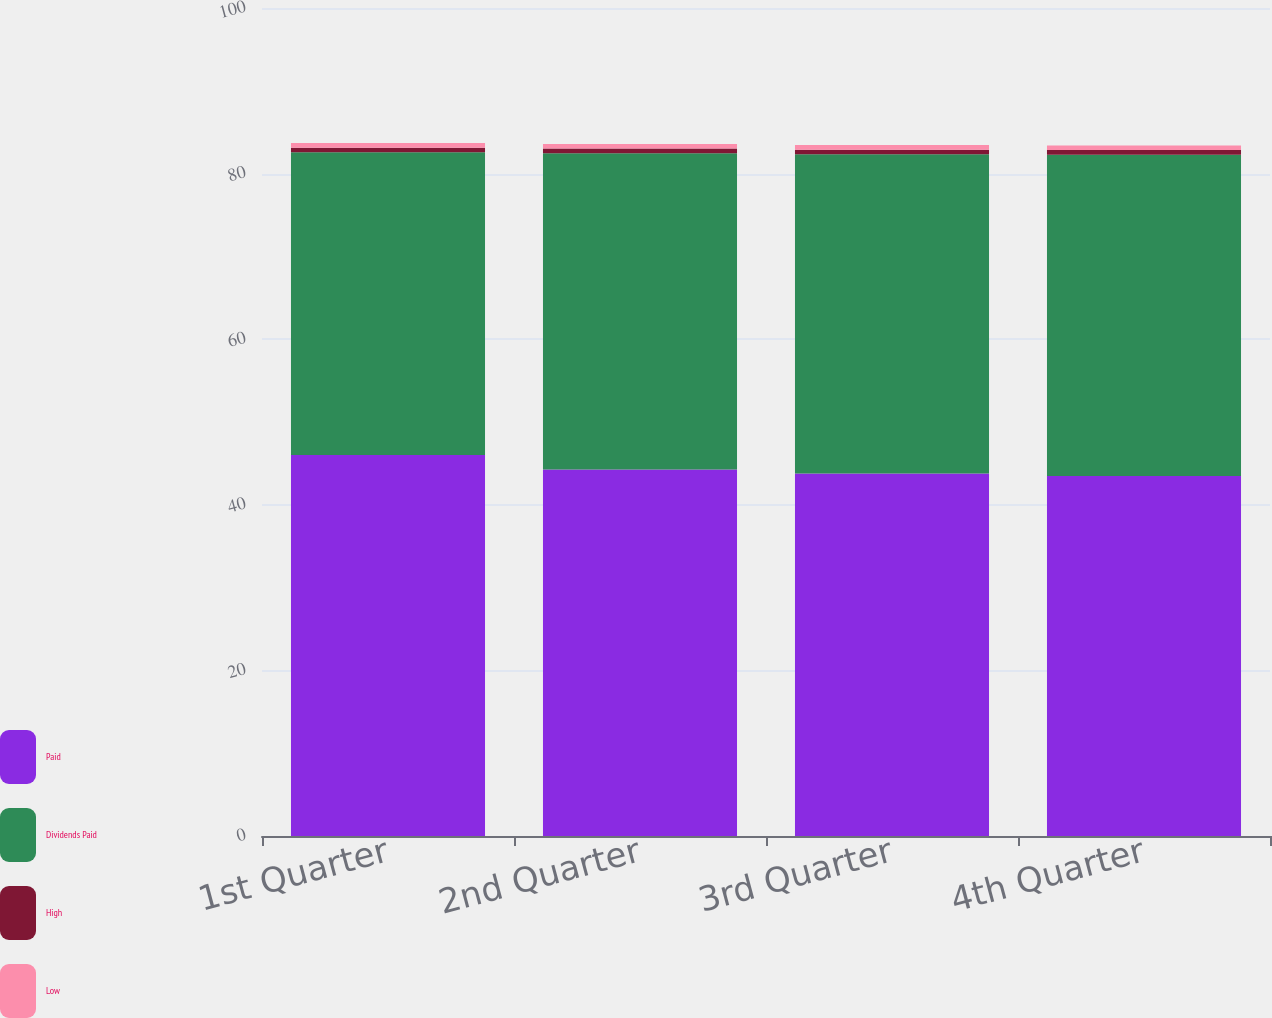<chart> <loc_0><loc_0><loc_500><loc_500><stacked_bar_chart><ecel><fcel>1st Quarter<fcel>2nd Quarter<fcel>3rd Quarter<fcel>4th Quarter<nl><fcel>Paid<fcel>46.02<fcel>44.26<fcel>43.78<fcel>43.48<nl><fcel>Dividends Paid<fcel>36.55<fcel>38.2<fcel>38.55<fcel>38.8<nl><fcel>High<fcel>0.56<fcel>0.56<fcel>0.56<fcel>0.56<nl><fcel>Low<fcel>0.56<fcel>0.56<fcel>0.56<fcel>0.56<nl></chart> 